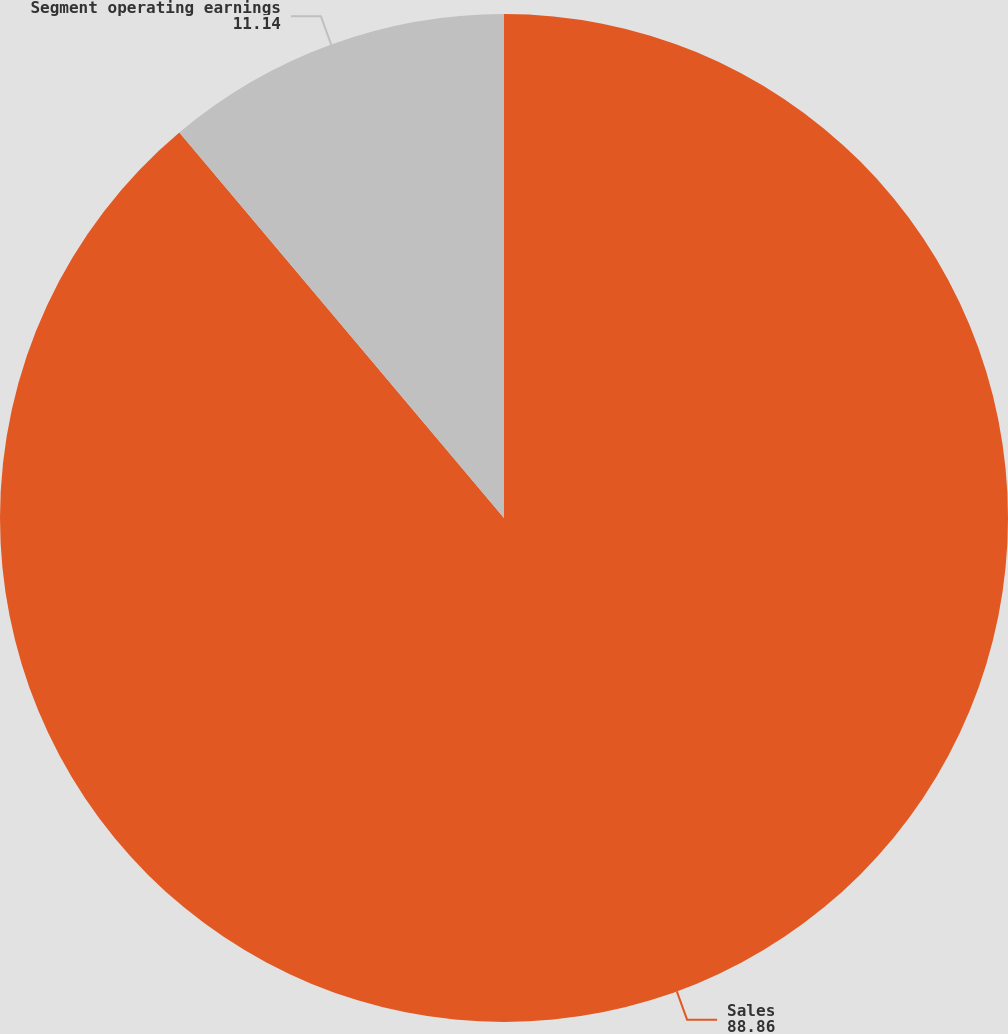Convert chart to OTSL. <chart><loc_0><loc_0><loc_500><loc_500><pie_chart><fcel>Sales<fcel>Segment operating earnings<nl><fcel>88.86%<fcel>11.14%<nl></chart> 